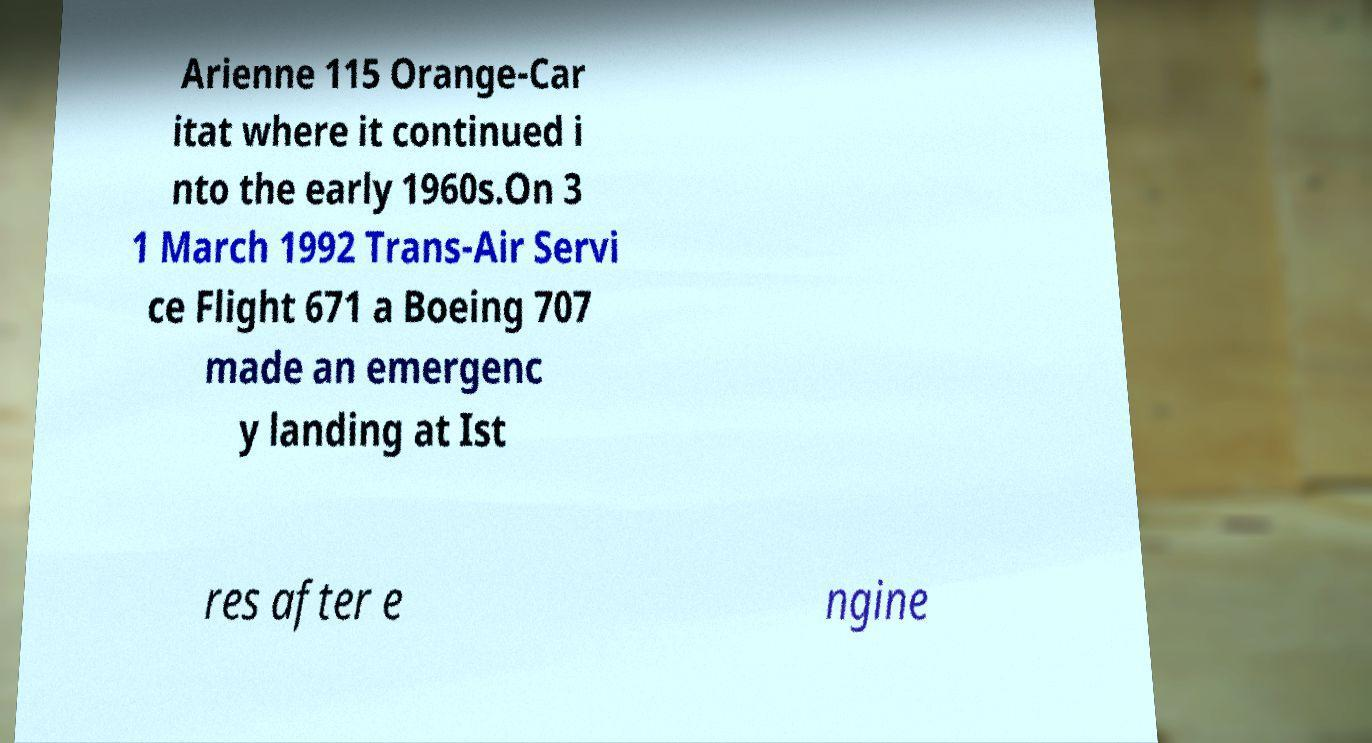I need the written content from this picture converted into text. Can you do that? Arienne 115 Orange-Car itat where it continued i nto the early 1960s.On 3 1 March 1992 Trans-Air Servi ce Flight 671 a Boeing 707 made an emergenc y landing at Ist res after e ngine 